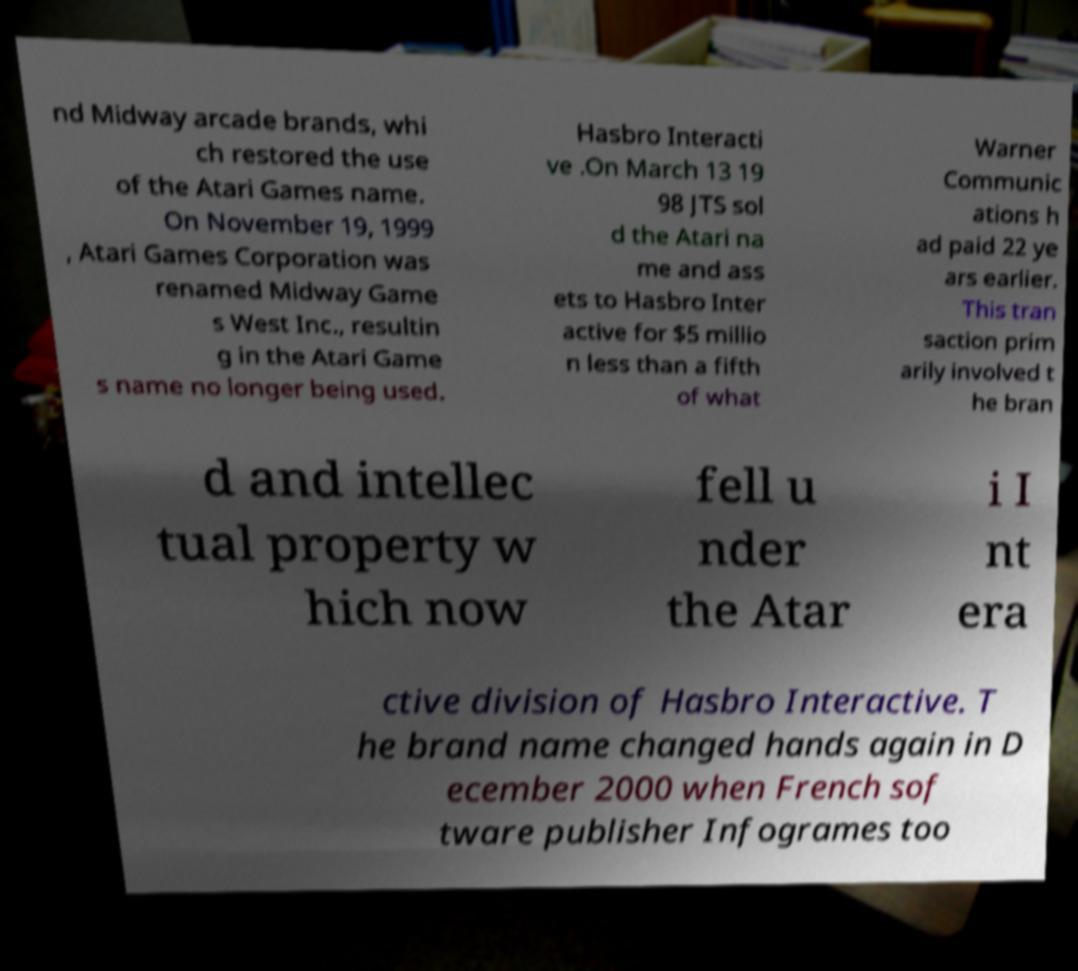What messages or text are displayed in this image? I need them in a readable, typed format. nd Midway arcade brands, whi ch restored the use of the Atari Games name. On November 19, 1999 , Atari Games Corporation was renamed Midway Game s West Inc., resultin g in the Atari Game s name no longer being used. Hasbro Interacti ve .On March 13 19 98 JTS sol d the Atari na me and ass ets to Hasbro Inter active for $5 millio n less than a fifth of what Warner Communic ations h ad paid 22 ye ars earlier. This tran saction prim arily involved t he bran d and intellec tual property w hich now fell u nder the Atar i I nt era ctive division of Hasbro Interactive. T he brand name changed hands again in D ecember 2000 when French sof tware publisher Infogrames too 